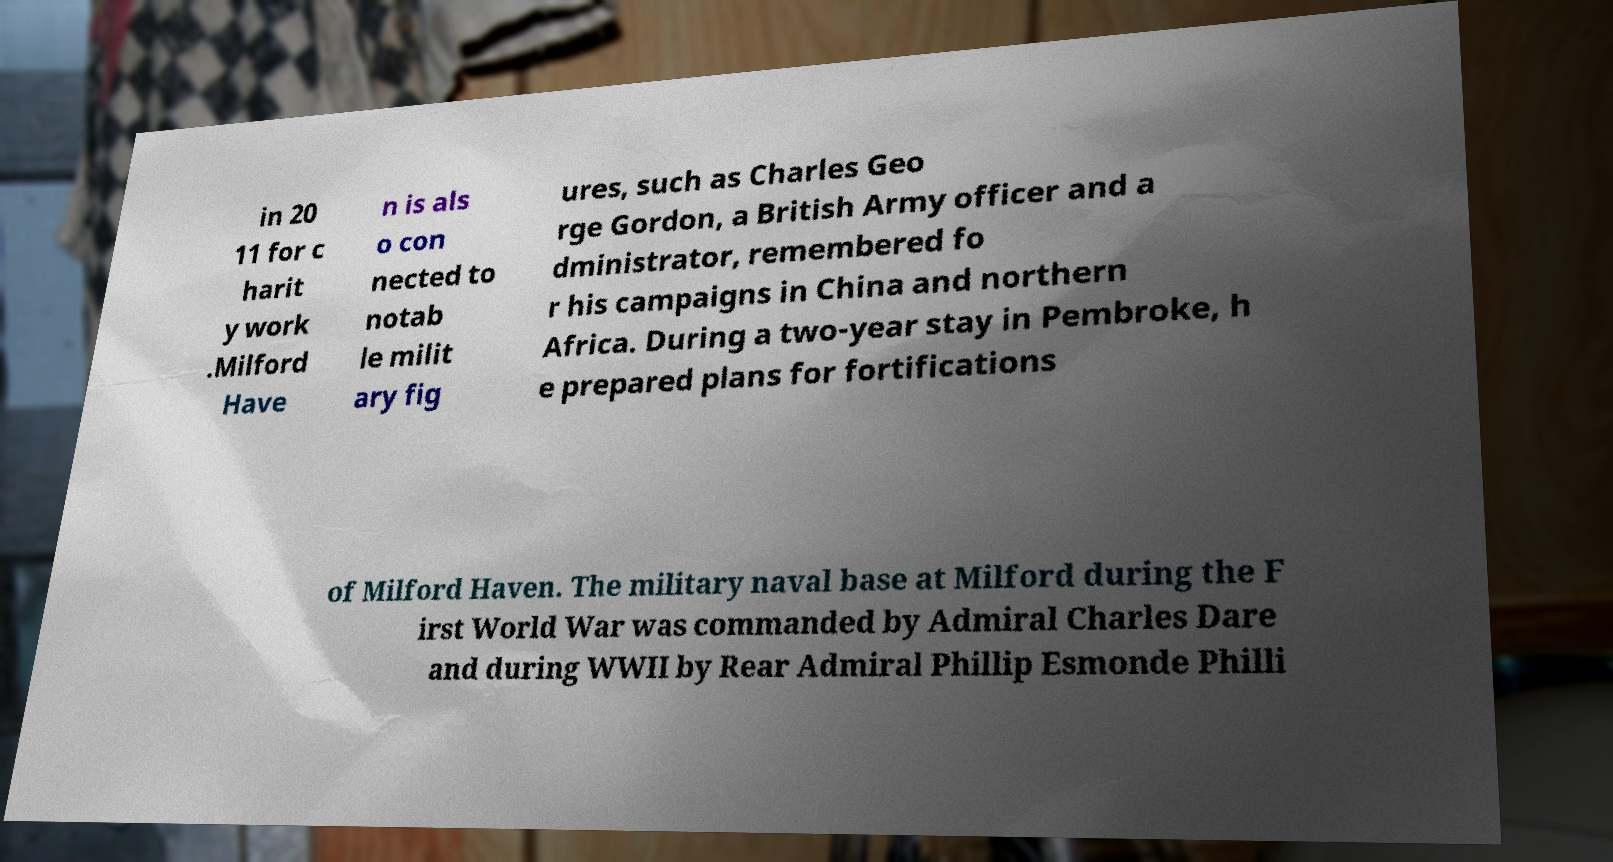What messages or text are displayed in this image? I need them in a readable, typed format. in 20 11 for c harit y work .Milford Have n is als o con nected to notab le milit ary fig ures, such as Charles Geo rge Gordon, a British Army officer and a dministrator, remembered fo r his campaigns in China and northern Africa. During a two-year stay in Pembroke, h e prepared plans for fortifications of Milford Haven. The military naval base at Milford during the F irst World War was commanded by Admiral Charles Dare and during WWII by Rear Admiral Phillip Esmonde Philli 